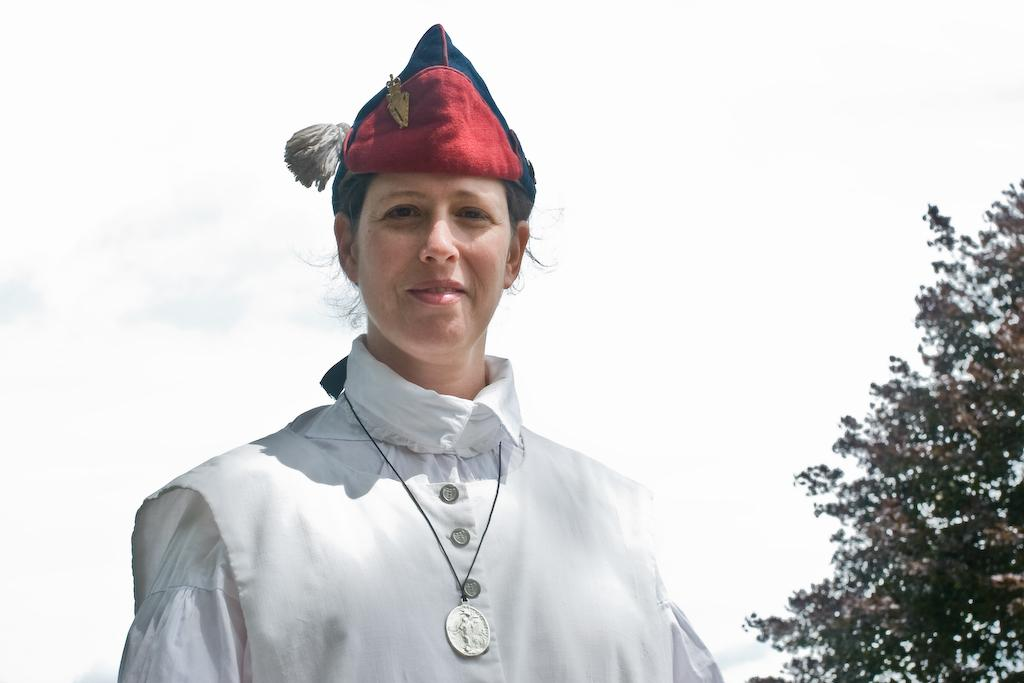Who is the main subject in the image? There is a woman in the image. What is the woman wearing? The woman is wearing a white dress. What expression does the woman have? The woman is smiling. What is the woman doing in the image? The woman is giving a pose for the picture. What can be seen on the right side of the image? There is a tree on the right side of the image. What is visible in the background of the image? The sky is visible in the background of the image. What is the woman discussing with the tree in the image? There is no discussion taking place between the woman and the tree in the image. The woman is posing for a picture, and the tree is simply a part of the background. 